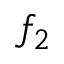Convert formula to latex. <formula><loc_0><loc_0><loc_500><loc_500>f _ { 2 }</formula> 